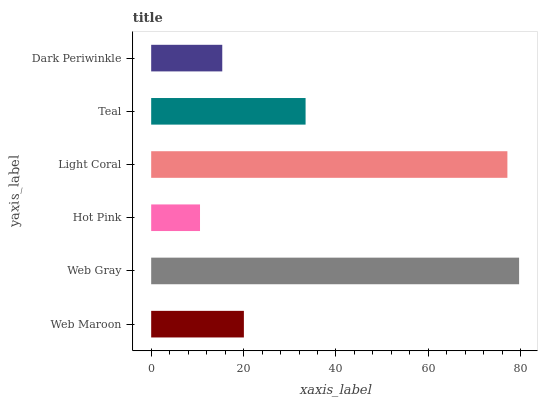Is Hot Pink the minimum?
Answer yes or no. Yes. Is Web Gray the maximum?
Answer yes or no. Yes. Is Web Gray the minimum?
Answer yes or no. No. Is Hot Pink the maximum?
Answer yes or no. No. Is Web Gray greater than Hot Pink?
Answer yes or no. Yes. Is Hot Pink less than Web Gray?
Answer yes or no. Yes. Is Hot Pink greater than Web Gray?
Answer yes or no. No. Is Web Gray less than Hot Pink?
Answer yes or no. No. Is Teal the high median?
Answer yes or no. Yes. Is Web Maroon the low median?
Answer yes or no. Yes. Is Light Coral the high median?
Answer yes or no. No. Is Web Gray the low median?
Answer yes or no. No. 